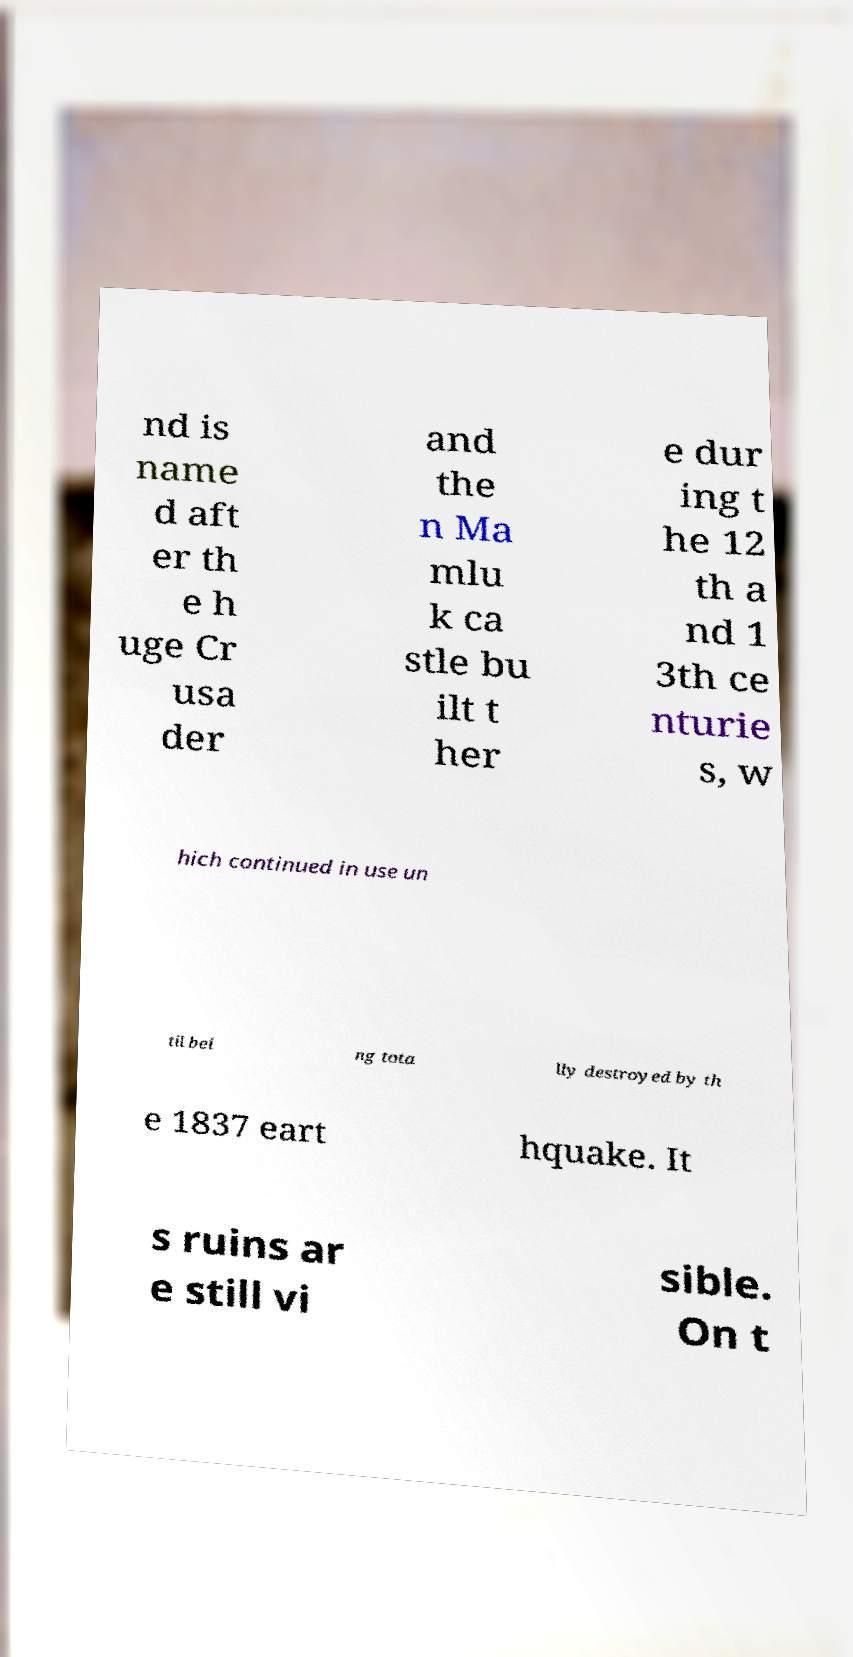For documentation purposes, I need the text within this image transcribed. Could you provide that? nd is name d aft er th e h uge Cr usa der and the n Ma mlu k ca stle bu ilt t her e dur ing t he 12 th a nd 1 3th ce nturie s, w hich continued in use un til bei ng tota lly destroyed by th e 1837 eart hquake. It s ruins ar e still vi sible. On t 